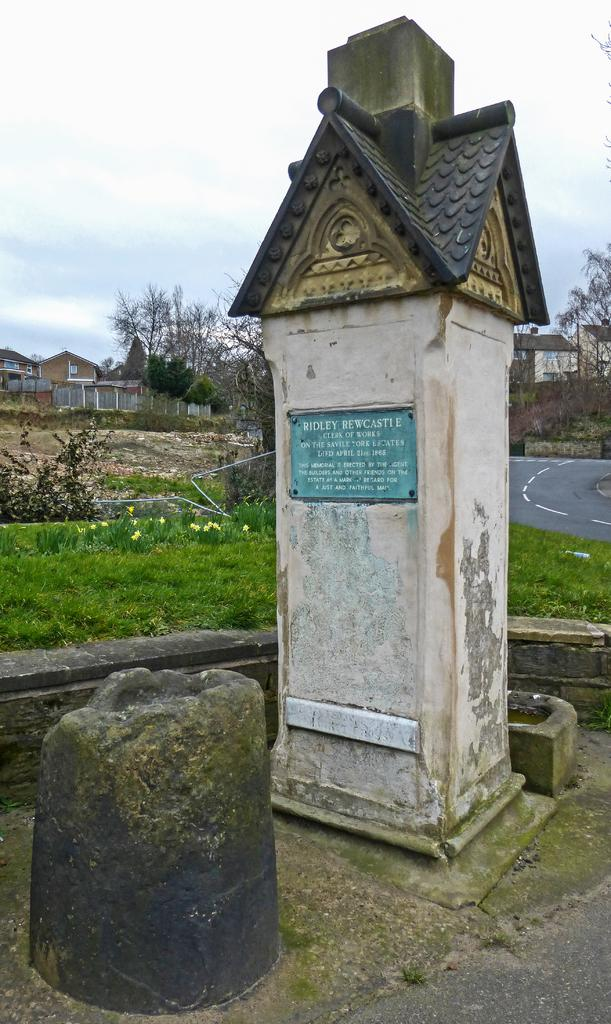What type of surface is visible in the image? There are laid stones in the image. What else can be seen in the image besides the laid stones? There is a road, buildings, trees, and the sky visible in the image. What is the condition of the sky in the image? The sky is visible in the image, and there are clouds in the sky. Can you see any stars in the image? There are no stars visible in the image. What type of fear is depicted in the image? There is no fear depicted in the image; it features laid stones, a road, buildings, trees, and the sky. 